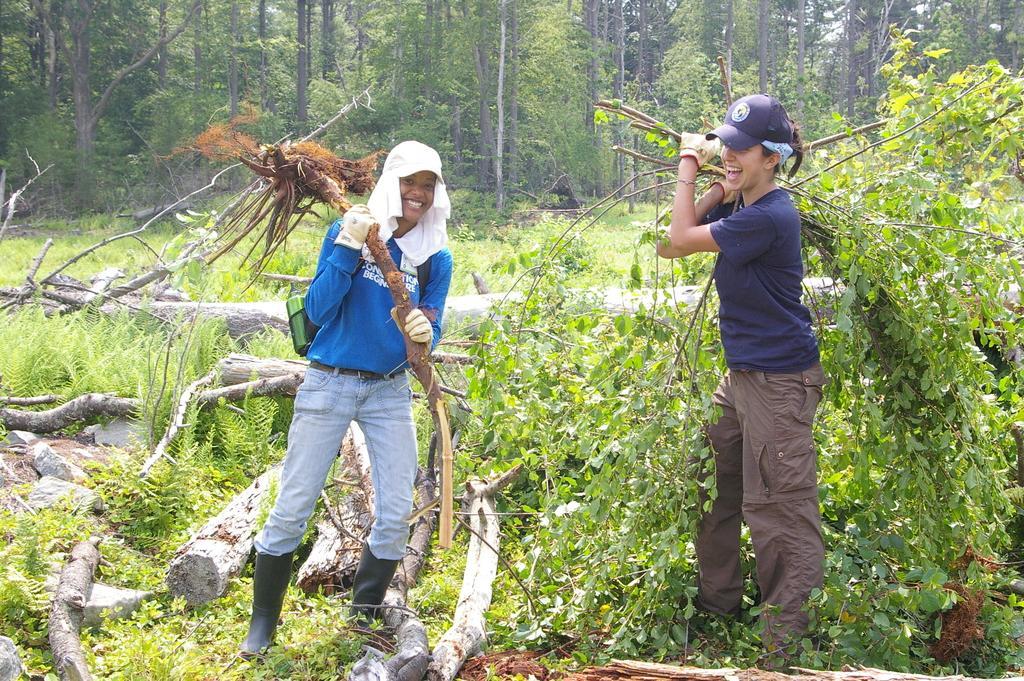How would you summarize this image in a sentence or two? In this image we can see two persons standing and smiling, there are some plants and wood on the ground, in the background, we can see the trees. 